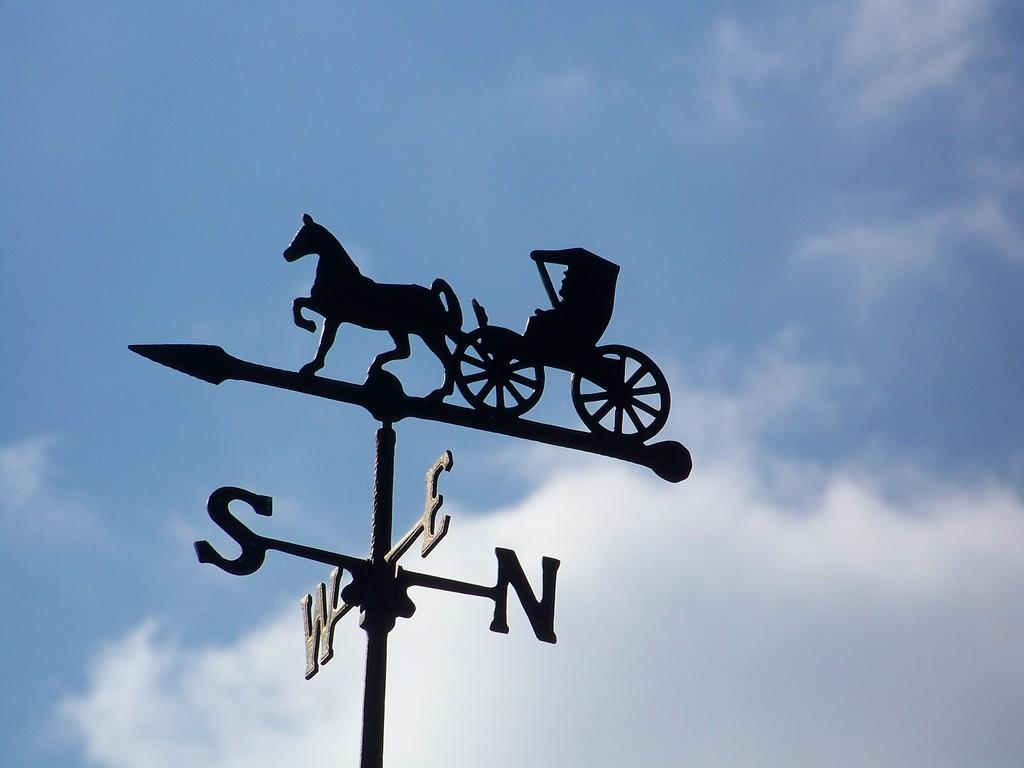What is the main object in the image? There is a direction pole in the image. What is attached to the direction pole? A horse cart is present on the pole. What can be seen in the background of the image? The sky is visible in the background of the image. How would you describe the sky in the image? The sky appears to be cloudy. How many pets are sitting on the sheet in the image? There are no pets or sheets present in the image; it features a direction pole with a horse cart and a cloudy sky in the background. 